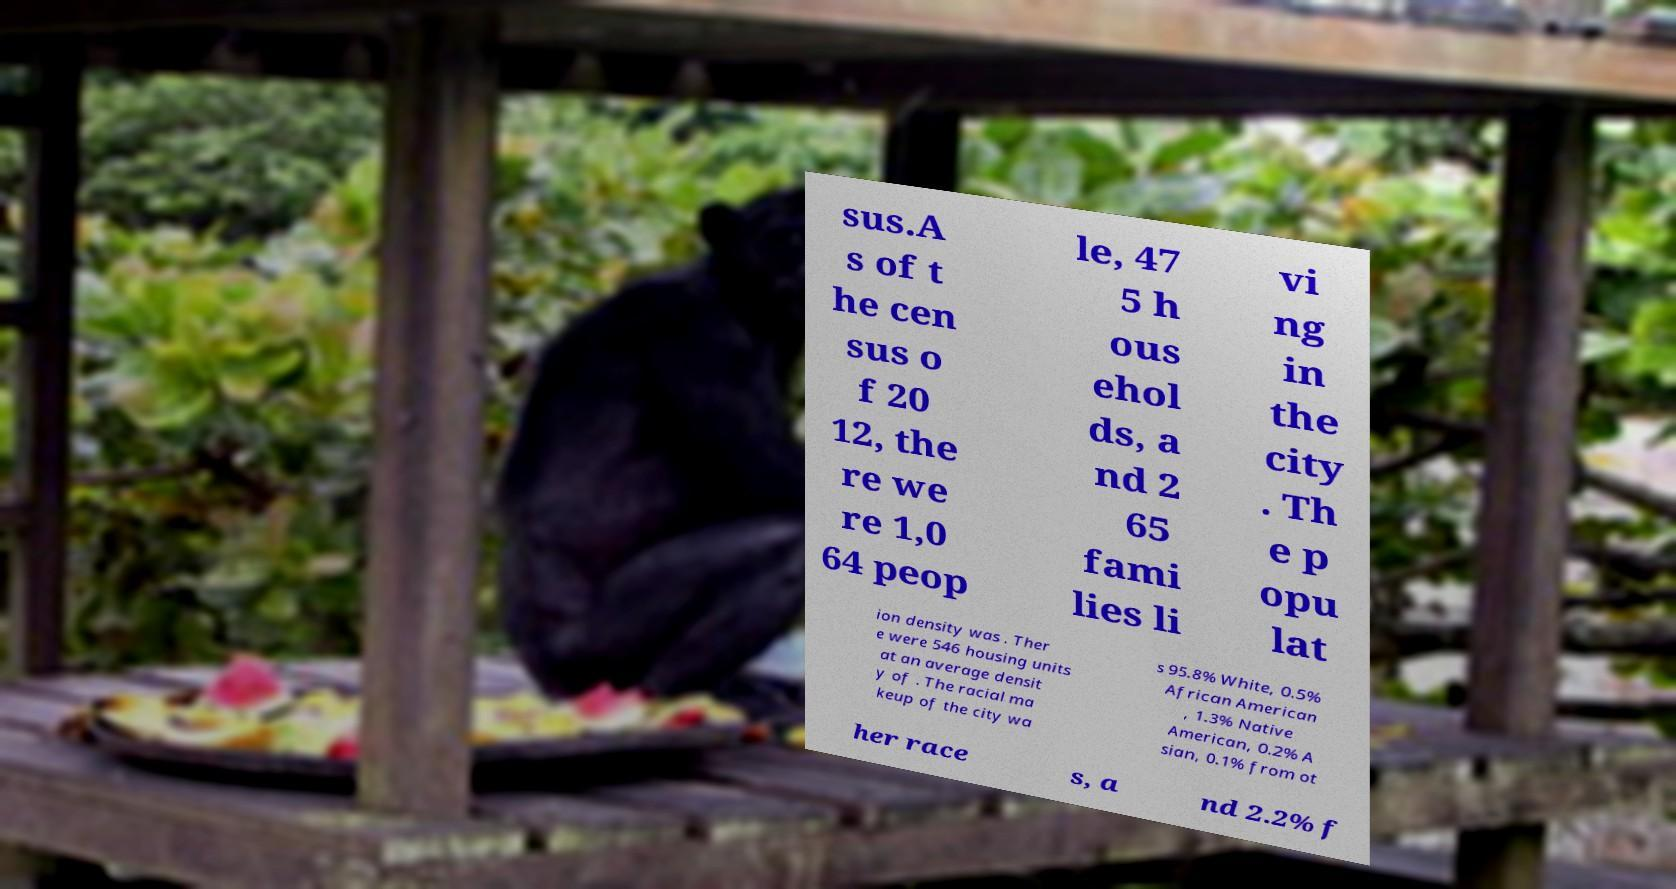Could you assist in decoding the text presented in this image and type it out clearly? sus.A s of t he cen sus o f 20 12, the re we re 1,0 64 peop le, 47 5 h ous ehol ds, a nd 2 65 fami lies li vi ng in the city . Th e p opu lat ion density was . Ther e were 546 housing units at an average densit y of . The racial ma keup of the city wa s 95.8% White, 0.5% African American , 1.3% Native American, 0.2% A sian, 0.1% from ot her race s, a nd 2.2% f 